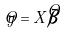Convert formula to latex. <formula><loc_0><loc_0><loc_500><loc_500>\hat { y } = X \hat { \beta }</formula> 